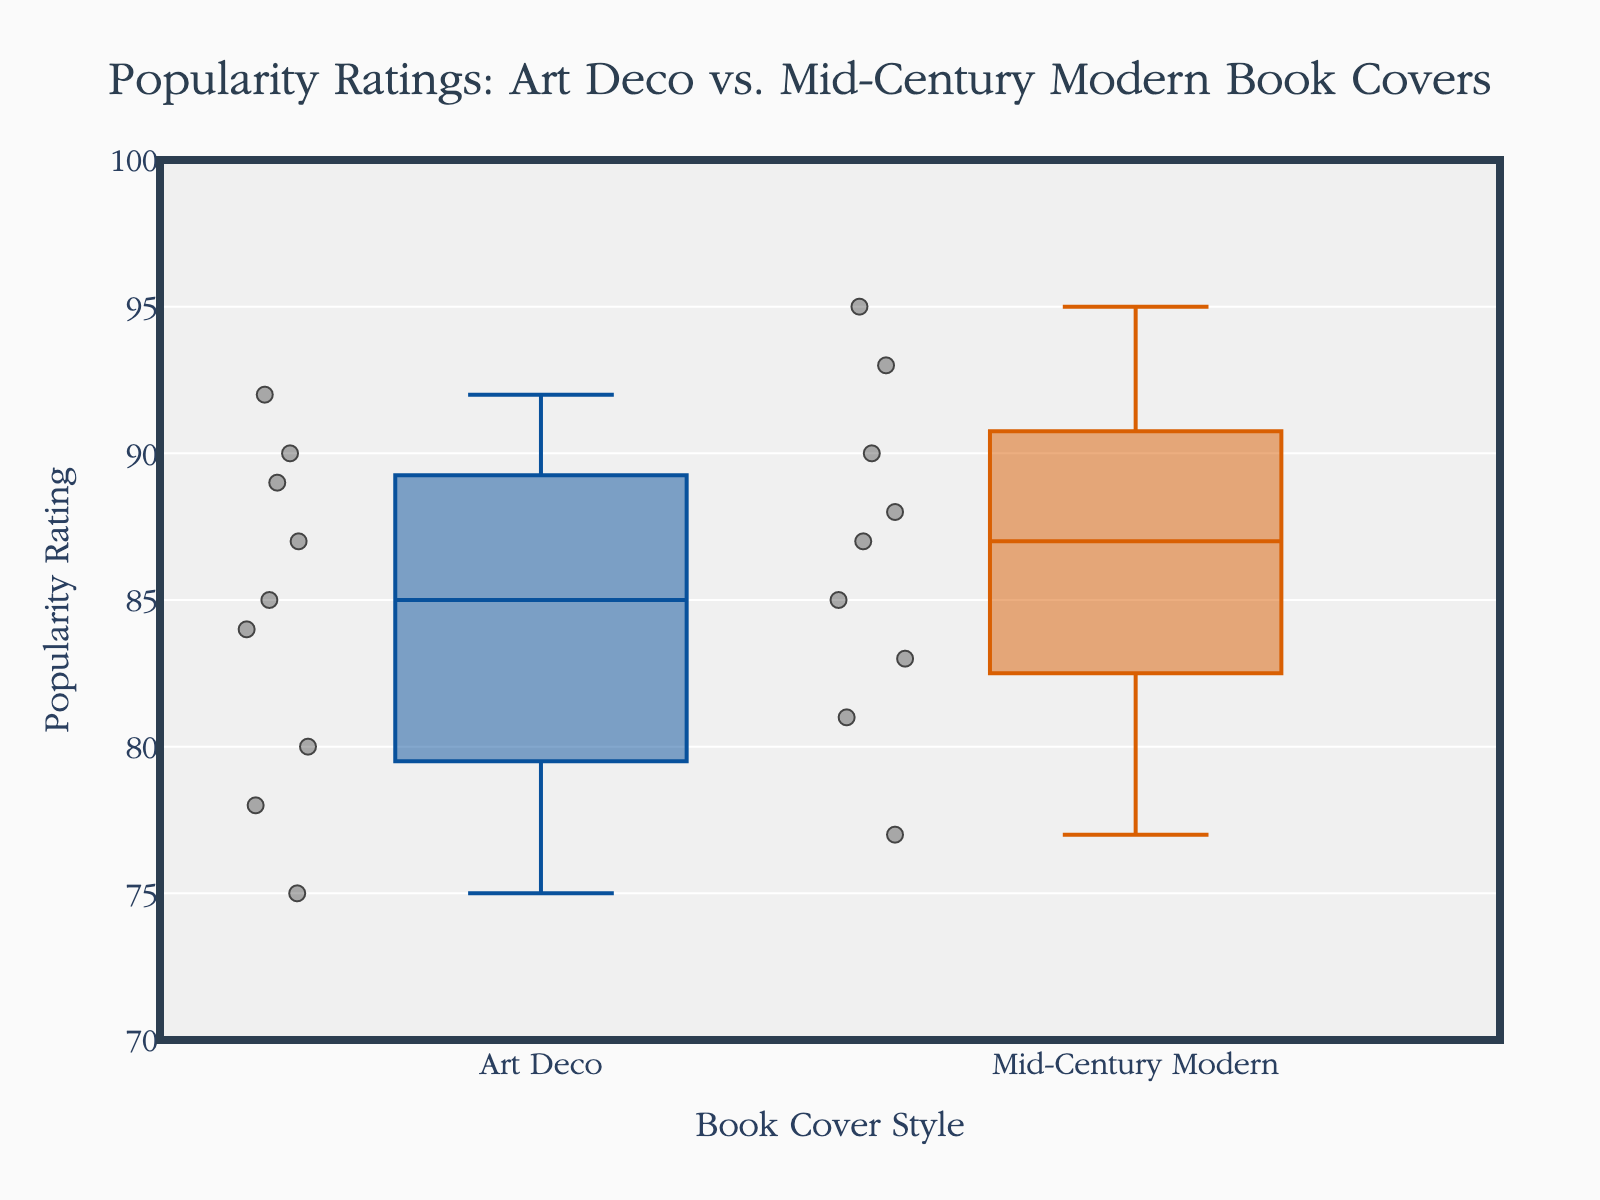What's the title of the figure? The title is displayed at the top of the figure. It reads "Popularity Ratings: Art Deco vs. Mid-Century Modern Book Covers."
Answer: Popularity Ratings: Art Deco vs. Mid-Century Modern Book Covers Which style has a higher median popularity rating? The median is the middle value of the data points. For Art Deco, the median falls around 85. For Mid-Century Modern, the median is higher and falls around 87.
Answer: Mid-Century Modern What's the range of popularity ratings for Art Deco book covers? The range is the difference between the maximum and minimum values. The minimum popularity rating for Art Deco is 75, and the maximum is 92. Therefore, the range is 92 - 75.
Answer: 17 Which style has more variability in popularity ratings? Variability can be observed by the interquartile range (IQR) and the spread of data points. Art Deco has a wider spread from 75 to 92, while Mid-Century Modern ranges from 77 to 95. Art Deco's ratings are more spread out.
Answer: Art Deco What's the popularity rating of "The Maltese Falcon"? This is a basic lookup. For Art Deco, "The Maltese Falcon" has a popularity rating of 80.
Answer: 80 Which style has the highest popularity rating, and what is it? The highest popularity rating can be found at the top of the Mid-Century Modern group, which is 95 for "To Kill a Mockingbird."
Answer: Mid-Century Modern, 95 What is the average popularity rating for Mid-Century Modern book covers? Sum the ratings: 88 + 95 + 83 + 90 + 87 + 93 + 81 + 85 + 77 = 779. Divide by the number of books, which is 9. 779 / 9 ≈ 86.56.
Answer: 86.56 Which style has more data points, and how many are there? Count the individual data points represented by the markers in each group. Both styles have 9 data points each.
Answer: Both have 9 Are there any outliers in the popularity ratings for Mid-Century Modern book covers? Outliers are usually displayed as individual points outside the whiskers of a box plot. For Mid-Century Modern, all data points fall within the whiskers, indicating no outliers.
Answer: No What is the interquartile range (IQR) for Art Deco? The IQR is the difference between the 75th percentile (upper quartile) and the 25th percentile (lower quartile). The lower quartile is around 78, and the upper quartile is around 89. Thus, IQR = 89 - 78.
Answer: 11 